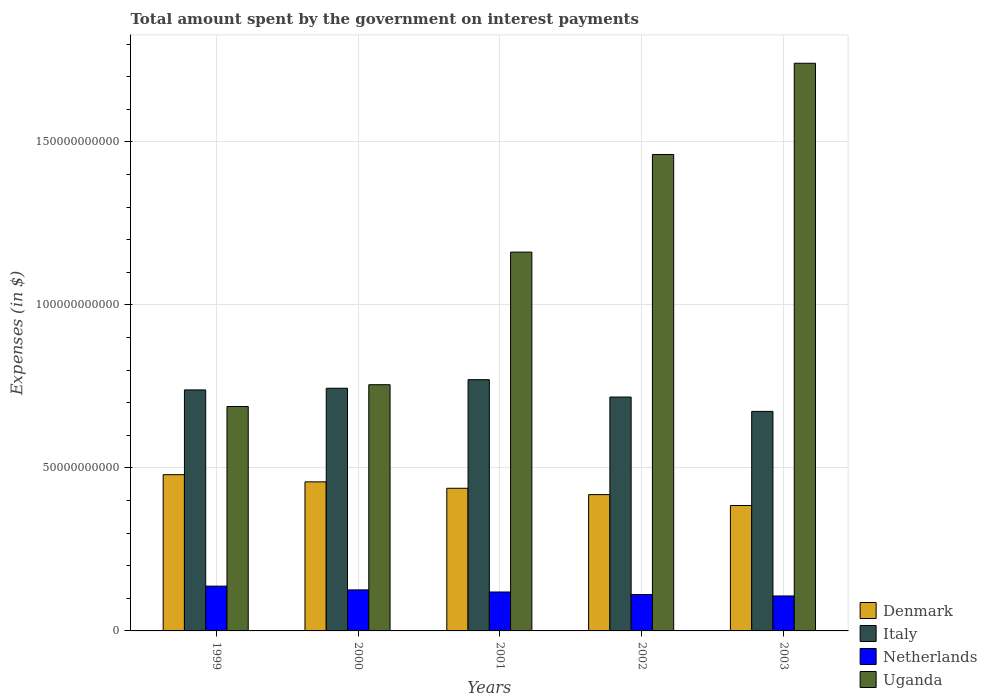How many groups of bars are there?
Offer a very short reply. 5. Are the number of bars per tick equal to the number of legend labels?
Make the answer very short. Yes. Are the number of bars on each tick of the X-axis equal?
Provide a succinct answer. Yes. How many bars are there on the 3rd tick from the left?
Make the answer very short. 4. What is the label of the 4th group of bars from the left?
Ensure brevity in your answer.  2002. What is the amount spent on interest payments by the government in Italy in 2000?
Your answer should be compact. 7.44e+1. Across all years, what is the maximum amount spent on interest payments by the government in Italy?
Your response must be concise. 7.71e+1. Across all years, what is the minimum amount spent on interest payments by the government in Uganda?
Provide a succinct answer. 6.88e+1. In which year was the amount spent on interest payments by the government in Netherlands minimum?
Keep it short and to the point. 2003. What is the total amount spent on interest payments by the government in Denmark in the graph?
Provide a short and direct response. 2.18e+11. What is the difference between the amount spent on interest payments by the government in Denmark in 2001 and that in 2003?
Provide a succinct answer. 5.29e+09. What is the difference between the amount spent on interest payments by the government in Italy in 2000 and the amount spent on interest payments by the government in Netherlands in 1999?
Provide a succinct answer. 6.07e+1. What is the average amount spent on interest payments by the government in Italy per year?
Make the answer very short. 7.29e+1. In the year 2001, what is the difference between the amount spent on interest payments by the government in Italy and amount spent on interest payments by the government in Denmark?
Offer a terse response. 3.33e+1. What is the ratio of the amount spent on interest payments by the government in Denmark in 1999 to that in 2002?
Your answer should be very brief. 1.15. Is the difference between the amount spent on interest payments by the government in Italy in 2000 and 2001 greater than the difference between the amount spent on interest payments by the government in Denmark in 2000 and 2001?
Ensure brevity in your answer.  No. What is the difference between the highest and the second highest amount spent on interest payments by the government in Uganda?
Your answer should be very brief. 2.80e+1. What is the difference between the highest and the lowest amount spent on interest payments by the government in Denmark?
Your response must be concise. 9.46e+09. What does the 2nd bar from the left in 2002 represents?
Give a very brief answer. Italy. Is it the case that in every year, the sum of the amount spent on interest payments by the government in Italy and amount spent on interest payments by the government in Netherlands is greater than the amount spent on interest payments by the government in Uganda?
Your answer should be very brief. No. How many bars are there?
Give a very brief answer. 20. Are all the bars in the graph horizontal?
Make the answer very short. No. How many years are there in the graph?
Ensure brevity in your answer.  5. What is the difference between two consecutive major ticks on the Y-axis?
Provide a short and direct response. 5.00e+1. How many legend labels are there?
Your answer should be very brief. 4. What is the title of the graph?
Your answer should be compact. Total amount spent by the government on interest payments. What is the label or title of the X-axis?
Offer a terse response. Years. What is the label or title of the Y-axis?
Provide a short and direct response. Expenses (in $). What is the Expenses (in $) in Denmark in 1999?
Give a very brief answer. 4.79e+1. What is the Expenses (in $) of Italy in 1999?
Offer a very short reply. 7.39e+1. What is the Expenses (in $) of Netherlands in 1999?
Make the answer very short. 1.37e+1. What is the Expenses (in $) in Uganda in 1999?
Offer a terse response. 6.88e+1. What is the Expenses (in $) in Denmark in 2000?
Offer a very short reply. 4.57e+1. What is the Expenses (in $) in Italy in 2000?
Ensure brevity in your answer.  7.44e+1. What is the Expenses (in $) of Netherlands in 2000?
Provide a short and direct response. 1.26e+1. What is the Expenses (in $) in Uganda in 2000?
Provide a short and direct response. 7.55e+1. What is the Expenses (in $) of Denmark in 2001?
Keep it short and to the point. 4.38e+1. What is the Expenses (in $) in Italy in 2001?
Ensure brevity in your answer.  7.71e+1. What is the Expenses (in $) in Netherlands in 2001?
Give a very brief answer. 1.19e+1. What is the Expenses (in $) in Uganda in 2001?
Your answer should be very brief. 1.16e+11. What is the Expenses (in $) in Denmark in 2002?
Offer a terse response. 4.18e+1. What is the Expenses (in $) in Italy in 2002?
Your response must be concise. 7.17e+1. What is the Expenses (in $) in Netherlands in 2002?
Ensure brevity in your answer.  1.12e+1. What is the Expenses (in $) of Uganda in 2002?
Ensure brevity in your answer.  1.46e+11. What is the Expenses (in $) in Denmark in 2003?
Provide a succinct answer. 3.85e+1. What is the Expenses (in $) of Italy in 2003?
Offer a very short reply. 6.73e+1. What is the Expenses (in $) of Netherlands in 2003?
Offer a very short reply. 1.07e+1. What is the Expenses (in $) in Uganda in 2003?
Make the answer very short. 1.74e+11. Across all years, what is the maximum Expenses (in $) of Denmark?
Ensure brevity in your answer.  4.79e+1. Across all years, what is the maximum Expenses (in $) in Italy?
Provide a short and direct response. 7.71e+1. Across all years, what is the maximum Expenses (in $) in Netherlands?
Your response must be concise. 1.37e+1. Across all years, what is the maximum Expenses (in $) in Uganda?
Your response must be concise. 1.74e+11. Across all years, what is the minimum Expenses (in $) of Denmark?
Your answer should be compact. 3.85e+1. Across all years, what is the minimum Expenses (in $) of Italy?
Offer a very short reply. 6.73e+1. Across all years, what is the minimum Expenses (in $) of Netherlands?
Offer a very short reply. 1.07e+1. Across all years, what is the minimum Expenses (in $) in Uganda?
Offer a very short reply. 6.88e+1. What is the total Expenses (in $) of Denmark in the graph?
Ensure brevity in your answer.  2.18e+11. What is the total Expenses (in $) in Italy in the graph?
Provide a short and direct response. 3.65e+11. What is the total Expenses (in $) in Netherlands in the graph?
Make the answer very short. 6.02e+1. What is the total Expenses (in $) in Uganda in the graph?
Provide a succinct answer. 5.81e+11. What is the difference between the Expenses (in $) of Denmark in 1999 and that in 2000?
Provide a succinct answer. 2.20e+09. What is the difference between the Expenses (in $) of Italy in 1999 and that in 2000?
Your answer should be very brief. -5.15e+08. What is the difference between the Expenses (in $) in Netherlands in 1999 and that in 2000?
Your answer should be very brief. 1.15e+09. What is the difference between the Expenses (in $) of Uganda in 1999 and that in 2000?
Your answer should be compact. -6.68e+09. What is the difference between the Expenses (in $) of Denmark in 1999 and that in 2001?
Provide a short and direct response. 4.17e+09. What is the difference between the Expenses (in $) in Italy in 1999 and that in 2001?
Provide a short and direct response. -3.14e+09. What is the difference between the Expenses (in $) in Netherlands in 1999 and that in 2001?
Offer a very short reply. 1.79e+09. What is the difference between the Expenses (in $) in Uganda in 1999 and that in 2001?
Make the answer very short. -4.74e+1. What is the difference between the Expenses (in $) in Denmark in 1999 and that in 2002?
Provide a succinct answer. 6.11e+09. What is the difference between the Expenses (in $) in Italy in 1999 and that in 2002?
Provide a succinct answer. 2.18e+09. What is the difference between the Expenses (in $) in Netherlands in 1999 and that in 2002?
Your response must be concise. 2.57e+09. What is the difference between the Expenses (in $) in Uganda in 1999 and that in 2002?
Give a very brief answer. -7.73e+1. What is the difference between the Expenses (in $) in Denmark in 1999 and that in 2003?
Provide a short and direct response. 9.46e+09. What is the difference between the Expenses (in $) of Italy in 1999 and that in 2003?
Your response must be concise. 6.58e+09. What is the difference between the Expenses (in $) in Netherlands in 1999 and that in 2003?
Make the answer very short. 3.01e+09. What is the difference between the Expenses (in $) of Uganda in 1999 and that in 2003?
Provide a succinct answer. -1.05e+11. What is the difference between the Expenses (in $) of Denmark in 2000 and that in 2001?
Your answer should be compact. 1.97e+09. What is the difference between the Expenses (in $) of Italy in 2000 and that in 2001?
Offer a very short reply. -2.63e+09. What is the difference between the Expenses (in $) of Netherlands in 2000 and that in 2001?
Your answer should be very brief. 6.42e+08. What is the difference between the Expenses (in $) in Uganda in 2000 and that in 2001?
Your response must be concise. -4.07e+1. What is the difference between the Expenses (in $) of Denmark in 2000 and that in 2002?
Make the answer very short. 3.92e+09. What is the difference between the Expenses (in $) of Italy in 2000 and that in 2002?
Your answer should be compact. 2.70e+09. What is the difference between the Expenses (in $) of Netherlands in 2000 and that in 2002?
Ensure brevity in your answer.  1.42e+09. What is the difference between the Expenses (in $) of Uganda in 2000 and that in 2002?
Provide a succinct answer. -7.06e+1. What is the difference between the Expenses (in $) of Denmark in 2000 and that in 2003?
Make the answer very short. 7.26e+09. What is the difference between the Expenses (in $) in Italy in 2000 and that in 2003?
Your answer should be compact. 7.10e+09. What is the difference between the Expenses (in $) in Netherlands in 2000 and that in 2003?
Offer a terse response. 1.86e+09. What is the difference between the Expenses (in $) of Uganda in 2000 and that in 2003?
Make the answer very short. -9.86e+1. What is the difference between the Expenses (in $) in Denmark in 2001 and that in 2002?
Provide a succinct answer. 1.95e+09. What is the difference between the Expenses (in $) in Italy in 2001 and that in 2002?
Offer a terse response. 5.33e+09. What is the difference between the Expenses (in $) in Netherlands in 2001 and that in 2002?
Ensure brevity in your answer.  7.79e+08. What is the difference between the Expenses (in $) of Uganda in 2001 and that in 2002?
Your answer should be very brief. -2.99e+1. What is the difference between the Expenses (in $) of Denmark in 2001 and that in 2003?
Your response must be concise. 5.29e+09. What is the difference between the Expenses (in $) of Italy in 2001 and that in 2003?
Offer a terse response. 9.73e+09. What is the difference between the Expenses (in $) of Netherlands in 2001 and that in 2003?
Keep it short and to the point. 1.22e+09. What is the difference between the Expenses (in $) of Uganda in 2001 and that in 2003?
Ensure brevity in your answer.  -5.79e+1. What is the difference between the Expenses (in $) of Denmark in 2002 and that in 2003?
Provide a short and direct response. 3.34e+09. What is the difference between the Expenses (in $) of Italy in 2002 and that in 2003?
Provide a succinct answer. 4.40e+09. What is the difference between the Expenses (in $) of Netherlands in 2002 and that in 2003?
Your answer should be very brief. 4.39e+08. What is the difference between the Expenses (in $) in Uganda in 2002 and that in 2003?
Provide a succinct answer. -2.80e+1. What is the difference between the Expenses (in $) of Denmark in 1999 and the Expenses (in $) of Italy in 2000?
Offer a very short reply. -2.65e+1. What is the difference between the Expenses (in $) of Denmark in 1999 and the Expenses (in $) of Netherlands in 2000?
Provide a succinct answer. 3.53e+1. What is the difference between the Expenses (in $) of Denmark in 1999 and the Expenses (in $) of Uganda in 2000?
Your answer should be compact. -2.76e+1. What is the difference between the Expenses (in $) of Italy in 1999 and the Expenses (in $) of Netherlands in 2000?
Make the answer very short. 6.13e+1. What is the difference between the Expenses (in $) in Italy in 1999 and the Expenses (in $) in Uganda in 2000?
Provide a succinct answer. -1.60e+09. What is the difference between the Expenses (in $) in Netherlands in 1999 and the Expenses (in $) in Uganda in 2000?
Offer a very short reply. -6.18e+1. What is the difference between the Expenses (in $) of Denmark in 1999 and the Expenses (in $) of Italy in 2001?
Give a very brief answer. -2.91e+1. What is the difference between the Expenses (in $) of Denmark in 1999 and the Expenses (in $) of Netherlands in 2001?
Provide a succinct answer. 3.60e+1. What is the difference between the Expenses (in $) in Denmark in 1999 and the Expenses (in $) in Uganda in 2001?
Offer a terse response. -6.83e+1. What is the difference between the Expenses (in $) in Italy in 1999 and the Expenses (in $) in Netherlands in 2001?
Keep it short and to the point. 6.20e+1. What is the difference between the Expenses (in $) of Italy in 1999 and the Expenses (in $) of Uganda in 2001?
Keep it short and to the point. -4.23e+1. What is the difference between the Expenses (in $) of Netherlands in 1999 and the Expenses (in $) of Uganda in 2001?
Give a very brief answer. -1.02e+11. What is the difference between the Expenses (in $) of Denmark in 1999 and the Expenses (in $) of Italy in 2002?
Offer a terse response. -2.38e+1. What is the difference between the Expenses (in $) of Denmark in 1999 and the Expenses (in $) of Netherlands in 2002?
Provide a short and direct response. 3.68e+1. What is the difference between the Expenses (in $) of Denmark in 1999 and the Expenses (in $) of Uganda in 2002?
Your answer should be compact. -9.82e+1. What is the difference between the Expenses (in $) in Italy in 1999 and the Expenses (in $) in Netherlands in 2002?
Ensure brevity in your answer.  6.28e+1. What is the difference between the Expenses (in $) in Italy in 1999 and the Expenses (in $) in Uganda in 2002?
Your answer should be very brief. -7.22e+1. What is the difference between the Expenses (in $) of Netherlands in 1999 and the Expenses (in $) of Uganda in 2002?
Make the answer very short. -1.32e+11. What is the difference between the Expenses (in $) in Denmark in 1999 and the Expenses (in $) in Italy in 2003?
Ensure brevity in your answer.  -1.94e+1. What is the difference between the Expenses (in $) of Denmark in 1999 and the Expenses (in $) of Netherlands in 2003?
Offer a terse response. 3.72e+1. What is the difference between the Expenses (in $) in Denmark in 1999 and the Expenses (in $) in Uganda in 2003?
Offer a very short reply. -1.26e+11. What is the difference between the Expenses (in $) in Italy in 1999 and the Expenses (in $) in Netherlands in 2003?
Your answer should be compact. 6.32e+1. What is the difference between the Expenses (in $) in Italy in 1999 and the Expenses (in $) in Uganda in 2003?
Offer a terse response. -1.00e+11. What is the difference between the Expenses (in $) in Netherlands in 1999 and the Expenses (in $) in Uganda in 2003?
Keep it short and to the point. -1.60e+11. What is the difference between the Expenses (in $) of Denmark in 2000 and the Expenses (in $) of Italy in 2001?
Provide a succinct answer. -3.13e+1. What is the difference between the Expenses (in $) in Denmark in 2000 and the Expenses (in $) in Netherlands in 2001?
Ensure brevity in your answer.  3.38e+1. What is the difference between the Expenses (in $) of Denmark in 2000 and the Expenses (in $) of Uganda in 2001?
Offer a terse response. -7.05e+1. What is the difference between the Expenses (in $) in Italy in 2000 and the Expenses (in $) in Netherlands in 2001?
Make the answer very short. 6.25e+1. What is the difference between the Expenses (in $) in Italy in 2000 and the Expenses (in $) in Uganda in 2001?
Provide a short and direct response. -4.18e+1. What is the difference between the Expenses (in $) in Netherlands in 2000 and the Expenses (in $) in Uganda in 2001?
Make the answer very short. -1.04e+11. What is the difference between the Expenses (in $) of Denmark in 2000 and the Expenses (in $) of Italy in 2002?
Ensure brevity in your answer.  -2.60e+1. What is the difference between the Expenses (in $) of Denmark in 2000 and the Expenses (in $) of Netherlands in 2002?
Keep it short and to the point. 3.46e+1. What is the difference between the Expenses (in $) of Denmark in 2000 and the Expenses (in $) of Uganda in 2002?
Keep it short and to the point. -1.00e+11. What is the difference between the Expenses (in $) of Italy in 2000 and the Expenses (in $) of Netherlands in 2002?
Your response must be concise. 6.33e+1. What is the difference between the Expenses (in $) in Italy in 2000 and the Expenses (in $) in Uganda in 2002?
Provide a short and direct response. -7.17e+1. What is the difference between the Expenses (in $) in Netherlands in 2000 and the Expenses (in $) in Uganda in 2002?
Keep it short and to the point. -1.34e+11. What is the difference between the Expenses (in $) in Denmark in 2000 and the Expenses (in $) in Italy in 2003?
Provide a short and direct response. -2.16e+1. What is the difference between the Expenses (in $) of Denmark in 2000 and the Expenses (in $) of Netherlands in 2003?
Keep it short and to the point. 3.50e+1. What is the difference between the Expenses (in $) in Denmark in 2000 and the Expenses (in $) in Uganda in 2003?
Provide a short and direct response. -1.28e+11. What is the difference between the Expenses (in $) of Italy in 2000 and the Expenses (in $) of Netherlands in 2003?
Your answer should be very brief. 6.37e+1. What is the difference between the Expenses (in $) in Italy in 2000 and the Expenses (in $) in Uganda in 2003?
Offer a very short reply. -9.97e+1. What is the difference between the Expenses (in $) in Netherlands in 2000 and the Expenses (in $) in Uganda in 2003?
Offer a terse response. -1.62e+11. What is the difference between the Expenses (in $) of Denmark in 2001 and the Expenses (in $) of Italy in 2002?
Provide a short and direct response. -2.80e+1. What is the difference between the Expenses (in $) of Denmark in 2001 and the Expenses (in $) of Netherlands in 2002?
Provide a short and direct response. 3.26e+1. What is the difference between the Expenses (in $) in Denmark in 2001 and the Expenses (in $) in Uganda in 2002?
Ensure brevity in your answer.  -1.02e+11. What is the difference between the Expenses (in $) of Italy in 2001 and the Expenses (in $) of Netherlands in 2002?
Make the answer very short. 6.59e+1. What is the difference between the Expenses (in $) of Italy in 2001 and the Expenses (in $) of Uganda in 2002?
Ensure brevity in your answer.  -6.91e+1. What is the difference between the Expenses (in $) in Netherlands in 2001 and the Expenses (in $) in Uganda in 2002?
Make the answer very short. -1.34e+11. What is the difference between the Expenses (in $) in Denmark in 2001 and the Expenses (in $) in Italy in 2003?
Ensure brevity in your answer.  -2.36e+1. What is the difference between the Expenses (in $) of Denmark in 2001 and the Expenses (in $) of Netherlands in 2003?
Your answer should be compact. 3.30e+1. What is the difference between the Expenses (in $) in Denmark in 2001 and the Expenses (in $) in Uganda in 2003?
Your answer should be very brief. -1.30e+11. What is the difference between the Expenses (in $) in Italy in 2001 and the Expenses (in $) in Netherlands in 2003?
Keep it short and to the point. 6.63e+1. What is the difference between the Expenses (in $) of Italy in 2001 and the Expenses (in $) of Uganda in 2003?
Offer a terse response. -9.71e+1. What is the difference between the Expenses (in $) in Netherlands in 2001 and the Expenses (in $) in Uganda in 2003?
Your response must be concise. -1.62e+11. What is the difference between the Expenses (in $) of Denmark in 2002 and the Expenses (in $) of Italy in 2003?
Offer a terse response. -2.55e+1. What is the difference between the Expenses (in $) in Denmark in 2002 and the Expenses (in $) in Netherlands in 2003?
Ensure brevity in your answer.  3.11e+1. What is the difference between the Expenses (in $) in Denmark in 2002 and the Expenses (in $) in Uganda in 2003?
Your answer should be very brief. -1.32e+11. What is the difference between the Expenses (in $) in Italy in 2002 and the Expenses (in $) in Netherlands in 2003?
Offer a terse response. 6.10e+1. What is the difference between the Expenses (in $) in Italy in 2002 and the Expenses (in $) in Uganda in 2003?
Offer a terse response. -1.02e+11. What is the difference between the Expenses (in $) in Netherlands in 2002 and the Expenses (in $) in Uganda in 2003?
Your answer should be compact. -1.63e+11. What is the average Expenses (in $) of Denmark per year?
Provide a succinct answer. 4.35e+1. What is the average Expenses (in $) in Italy per year?
Give a very brief answer. 7.29e+1. What is the average Expenses (in $) of Netherlands per year?
Your answer should be compact. 1.20e+1. What is the average Expenses (in $) of Uganda per year?
Give a very brief answer. 1.16e+11. In the year 1999, what is the difference between the Expenses (in $) of Denmark and Expenses (in $) of Italy?
Your response must be concise. -2.60e+1. In the year 1999, what is the difference between the Expenses (in $) in Denmark and Expenses (in $) in Netherlands?
Give a very brief answer. 3.42e+1. In the year 1999, what is the difference between the Expenses (in $) in Denmark and Expenses (in $) in Uganda?
Your answer should be compact. -2.09e+1. In the year 1999, what is the difference between the Expenses (in $) in Italy and Expenses (in $) in Netherlands?
Keep it short and to the point. 6.02e+1. In the year 1999, what is the difference between the Expenses (in $) in Italy and Expenses (in $) in Uganda?
Offer a terse response. 5.08e+09. In the year 1999, what is the difference between the Expenses (in $) in Netherlands and Expenses (in $) in Uganda?
Provide a succinct answer. -5.51e+1. In the year 2000, what is the difference between the Expenses (in $) in Denmark and Expenses (in $) in Italy?
Your response must be concise. -2.87e+1. In the year 2000, what is the difference between the Expenses (in $) of Denmark and Expenses (in $) of Netherlands?
Your answer should be compact. 3.31e+1. In the year 2000, what is the difference between the Expenses (in $) in Denmark and Expenses (in $) in Uganda?
Give a very brief answer. -2.98e+1. In the year 2000, what is the difference between the Expenses (in $) of Italy and Expenses (in $) of Netherlands?
Your answer should be compact. 6.19e+1. In the year 2000, what is the difference between the Expenses (in $) of Italy and Expenses (in $) of Uganda?
Give a very brief answer. -1.08e+09. In the year 2000, what is the difference between the Expenses (in $) of Netherlands and Expenses (in $) of Uganda?
Your answer should be very brief. -6.29e+1. In the year 2001, what is the difference between the Expenses (in $) of Denmark and Expenses (in $) of Italy?
Your answer should be very brief. -3.33e+1. In the year 2001, what is the difference between the Expenses (in $) in Denmark and Expenses (in $) in Netherlands?
Your response must be concise. 3.18e+1. In the year 2001, what is the difference between the Expenses (in $) in Denmark and Expenses (in $) in Uganda?
Ensure brevity in your answer.  -7.24e+1. In the year 2001, what is the difference between the Expenses (in $) of Italy and Expenses (in $) of Netherlands?
Offer a terse response. 6.51e+1. In the year 2001, what is the difference between the Expenses (in $) of Italy and Expenses (in $) of Uganda?
Offer a very short reply. -3.91e+1. In the year 2001, what is the difference between the Expenses (in $) in Netherlands and Expenses (in $) in Uganda?
Offer a very short reply. -1.04e+11. In the year 2002, what is the difference between the Expenses (in $) of Denmark and Expenses (in $) of Italy?
Provide a short and direct response. -2.99e+1. In the year 2002, what is the difference between the Expenses (in $) of Denmark and Expenses (in $) of Netherlands?
Ensure brevity in your answer.  3.06e+1. In the year 2002, what is the difference between the Expenses (in $) of Denmark and Expenses (in $) of Uganda?
Make the answer very short. -1.04e+11. In the year 2002, what is the difference between the Expenses (in $) in Italy and Expenses (in $) in Netherlands?
Give a very brief answer. 6.06e+1. In the year 2002, what is the difference between the Expenses (in $) in Italy and Expenses (in $) in Uganda?
Your answer should be very brief. -7.44e+1. In the year 2002, what is the difference between the Expenses (in $) of Netherlands and Expenses (in $) of Uganda?
Keep it short and to the point. -1.35e+11. In the year 2003, what is the difference between the Expenses (in $) in Denmark and Expenses (in $) in Italy?
Provide a succinct answer. -2.89e+1. In the year 2003, what is the difference between the Expenses (in $) of Denmark and Expenses (in $) of Netherlands?
Ensure brevity in your answer.  2.77e+1. In the year 2003, what is the difference between the Expenses (in $) in Denmark and Expenses (in $) in Uganda?
Offer a terse response. -1.36e+11. In the year 2003, what is the difference between the Expenses (in $) in Italy and Expenses (in $) in Netherlands?
Provide a succinct answer. 5.66e+1. In the year 2003, what is the difference between the Expenses (in $) in Italy and Expenses (in $) in Uganda?
Make the answer very short. -1.07e+11. In the year 2003, what is the difference between the Expenses (in $) of Netherlands and Expenses (in $) of Uganda?
Keep it short and to the point. -1.63e+11. What is the ratio of the Expenses (in $) in Denmark in 1999 to that in 2000?
Give a very brief answer. 1.05. What is the ratio of the Expenses (in $) of Netherlands in 1999 to that in 2000?
Ensure brevity in your answer.  1.09. What is the ratio of the Expenses (in $) of Uganda in 1999 to that in 2000?
Provide a short and direct response. 0.91. What is the ratio of the Expenses (in $) in Denmark in 1999 to that in 2001?
Make the answer very short. 1.1. What is the ratio of the Expenses (in $) in Italy in 1999 to that in 2001?
Provide a short and direct response. 0.96. What is the ratio of the Expenses (in $) of Netherlands in 1999 to that in 2001?
Offer a terse response. 1.15. What is the ratio of the Expenses (in $) of Uganda in 1999 to that in 2001?
Give a very brief answer. 0.59. What is the ratio of the Expenses (in $) of Denmark in 1999 to that in 2002?
Provide a succinct answer. 1.15. What is the ratio of the Expenses (in $) of Italy in 1999 to that in 2002?
Your answer should be compact. 1.03. What is the ratio of the Expenses (in $) of Netherlands in 1999 to that in 2002?
Provide a short and direct response. 1.23. What is the ratio of the Expenses (in $) of Uganda in 1999 to that in 2002?
Give a very brief answer. 0.47. What is the ratio of the Expenses (in $) of Denmark in 1999 to that in 2003?
Make the answer very short. 1.25. What is the ratio of the Expenses (in $) in Italy in 1999 to that in 2003?
Your response must be concise. 1.1. What is the ratio of the Expenses (in $) of Netherlands in 1999 to that in 2003?
Provide a succinct answer. 1.28. What is the ratio of the Expenses (in $) of Uganda in 1999 to that in 2003?
Offer a very short reply. 0.4. What is the ratio of the Expenses (in $) in Denmark in 2000 to that in 2001?
Your answer should be compact. 1.04. What is the ratio of the Expenses (in $) in Italy in 2000 to that in 2001?
Keep it short and to the point. 0.97. What is the ratio of the Expenses (in $) of Netherlands in 2000 to that in 2001?
Offer a very short reply. 1.05. What is the ratio of the Expenses (in $) in Uganda in 2000 to that in 2001?
Provide a short and direct response. 0.65. What is the ratio of the Expenses (in $) in Denmark in 2000 to that in 2002?
Offer a very short reply. 1.09. What is the ratio of the Expenses (in $) of Italy in 2000 to that in 2002?
Give a very brief answer. 1.04. What is the ratio of the Expenses (in $) in Netherlands in 2000 to that in 2002?
Your answer should be compact. 1.13. What is the ratio of the Expenses (in $) of Uganda in 2000 to that in 2002?
Offer a terse response. 0.52. What is the ratio of the Expenses (in $) in Denmark in 2000 to that in 2003?
Offer a terse response. 1.19. What is the ratio of the Expenses (in $) of Italy in 2000 to that in 2003?
Your answer should be very brief. 1.11. What is the ratio of the Expenses (in $) in Netherlands in 2000 to that in 2003?
Your response must be concise. 1.17. What is the ratio of the Expenses (in $) of Uganda in 2000 to that in 2003?
Make the answer very short. 0.43. What is the ratio of the Expenses (in $) in Denmark in 2001 to that in 2002?
Keep it short and to the point. 1.05. What is the ratio of the Expenses (in $) of Italy in 2001 to that in 2002?
Your answer should be compact. 1.07. What is the ratio of the Expenses (in $) of Netherlands in 2001 to that in 2002?
Keep it short and to the point. 1.07. What is the ratio of the Expenses (in $) in Uganda in 2001 to that in 2002?
Offer a very short reply. 0.8. What is the ratio of the Expenses (in $) in Denmark in 2001 to that in 2003?
Your answer should be compact. 1.14. What is the ratio of the Expenses (in $) of Italy in 2001 to that in 2003?
Provide a short and direct response. 1.14. What is the ratio of the Expenses (in $) of Netherlands in 2001 to that in 2003?
Your response must be concise. 1.11. What is the ratio of the Expenses (in $) in Uganda in 2001 to that in 2003?
Provide a succinct answer. 0.67. What is the ratio of the Expenses (in $) of Denmark in 2002 to that in 2003?
Your answer should be compact. 1.09. What is the ratio of the Expenses (in $) in Italy in 2002 to that in 2003?
Your answer should be very brief. 1.07. What is the ratio of the Expenses (in $) in Netherlands in 2002 to that in 2003?
Ensure brevity in your answer.  1.04. What is the ratio of the Expenses (in $) of Uganda in 2002 to that in 2003?
Provide a succinct answer. 0.84. What is the difference between the highest and the second highest Expenses (in $) of Denmark?
Ensure brevity in your answer.  2.20e+09. What is the difference between the highest and the second highest Expenses (in $) in Italy?
Your answer should be compact. 2.63e+09. What is the difference between the highest and the second highest Expenses (in $) in Netherlands?
Make the answer very short. 1.15e+09. What is the difference between the highest and the second highest Expenses (in $) of Uganda?
Offer a terse response. 2.80e+1. What is the difference between the highest and the lowest Expenses (in $) in Denmark?
Your answer should be very brief. 9.46e+09. What is the difference between the highest and the lowest Expenses (in $) in Italy?
Make the answer very short. 9.73e+09. What is the difference between the highest and the lowest Expenses (in $) of Netherlands?
Ensure brevity in your answer.  3.01e+09. What is the difference between the highest and the lowest Expenses (in $) in Uganda?
Provide a succinct answer. 1.05e+11. 